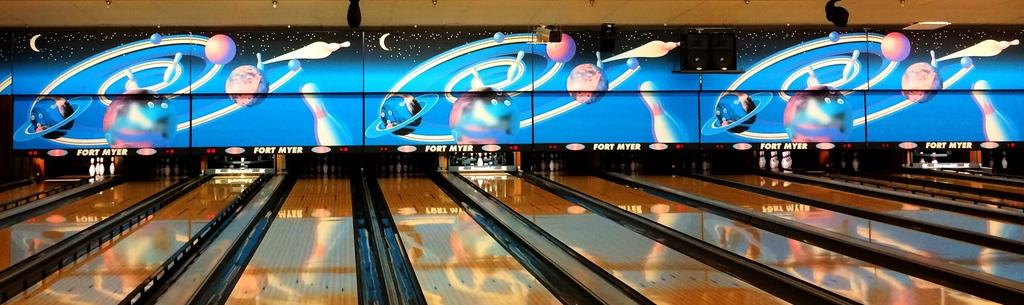What type of outdoor activity is featured in the image? There is a bowling game yard in the image. What is located above the bowling game yard? There is a screen above the bowling game yard. What type of jelly can be seen on the screen above the bowling game yard? There is no jelly present on the screen or in the image. How does the peace symbol relate to the bowling game yard in the image? There is no peace symbol present in the image, so it cannot be related to the bowling game yard. 